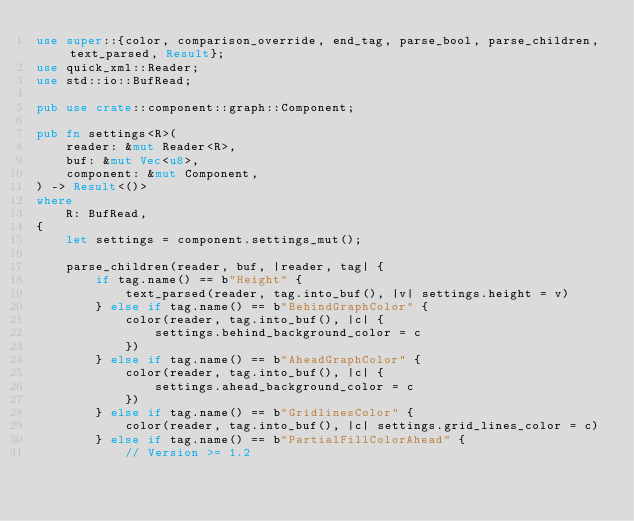Convert code to text. <code><loc_0><loc_0><loc_500><loc_500><_Rust_>use super::{color, comparison_override, end_tag, parse_bool, parse_children, text_parsed, Result};
use quick_xml::Reader;
use std::io::BufRead;

pub use crate::component::graph::Component;

pub fn settings<R>(
    reader: &mut Reader<R>,
    buf: &mut Vec<u8>,
    component: &mut Component,
) -> Result<()>
where
    R: BufRead,
{
    let settings = component.settings_mut();

    parse_children(reader, buf, |reader, tag| {
        if tag.name() == b"Height" {
            text_parsed(reader, tag.into_buf(), |v| settings.height = v)
        } else if tag.name() == b"BehindGraphColor" {
            color(reader, tag.into_buf(), |c| {
                settings.behind_background_color = c
            })
        } else if tag.name() == b"AheadGraphColor" {
            color(reader, tag.into_buf(), |c| {
                settings.ahead_background_color = c
            })
        } else if tag.name() == b"GridlinesColor" {
            color(reader, tag.into_buf(), |c| settings.grid_lines_color = c)
        } else if tag.name() == b"PartialFillColorAhead" {
            // Version >= 1.2</code> 